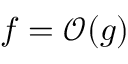Convert formula to latex. <formula><loc_0><loc_0><loc_500><loc_500>f = \mathcal { O } ( g )</formula> 